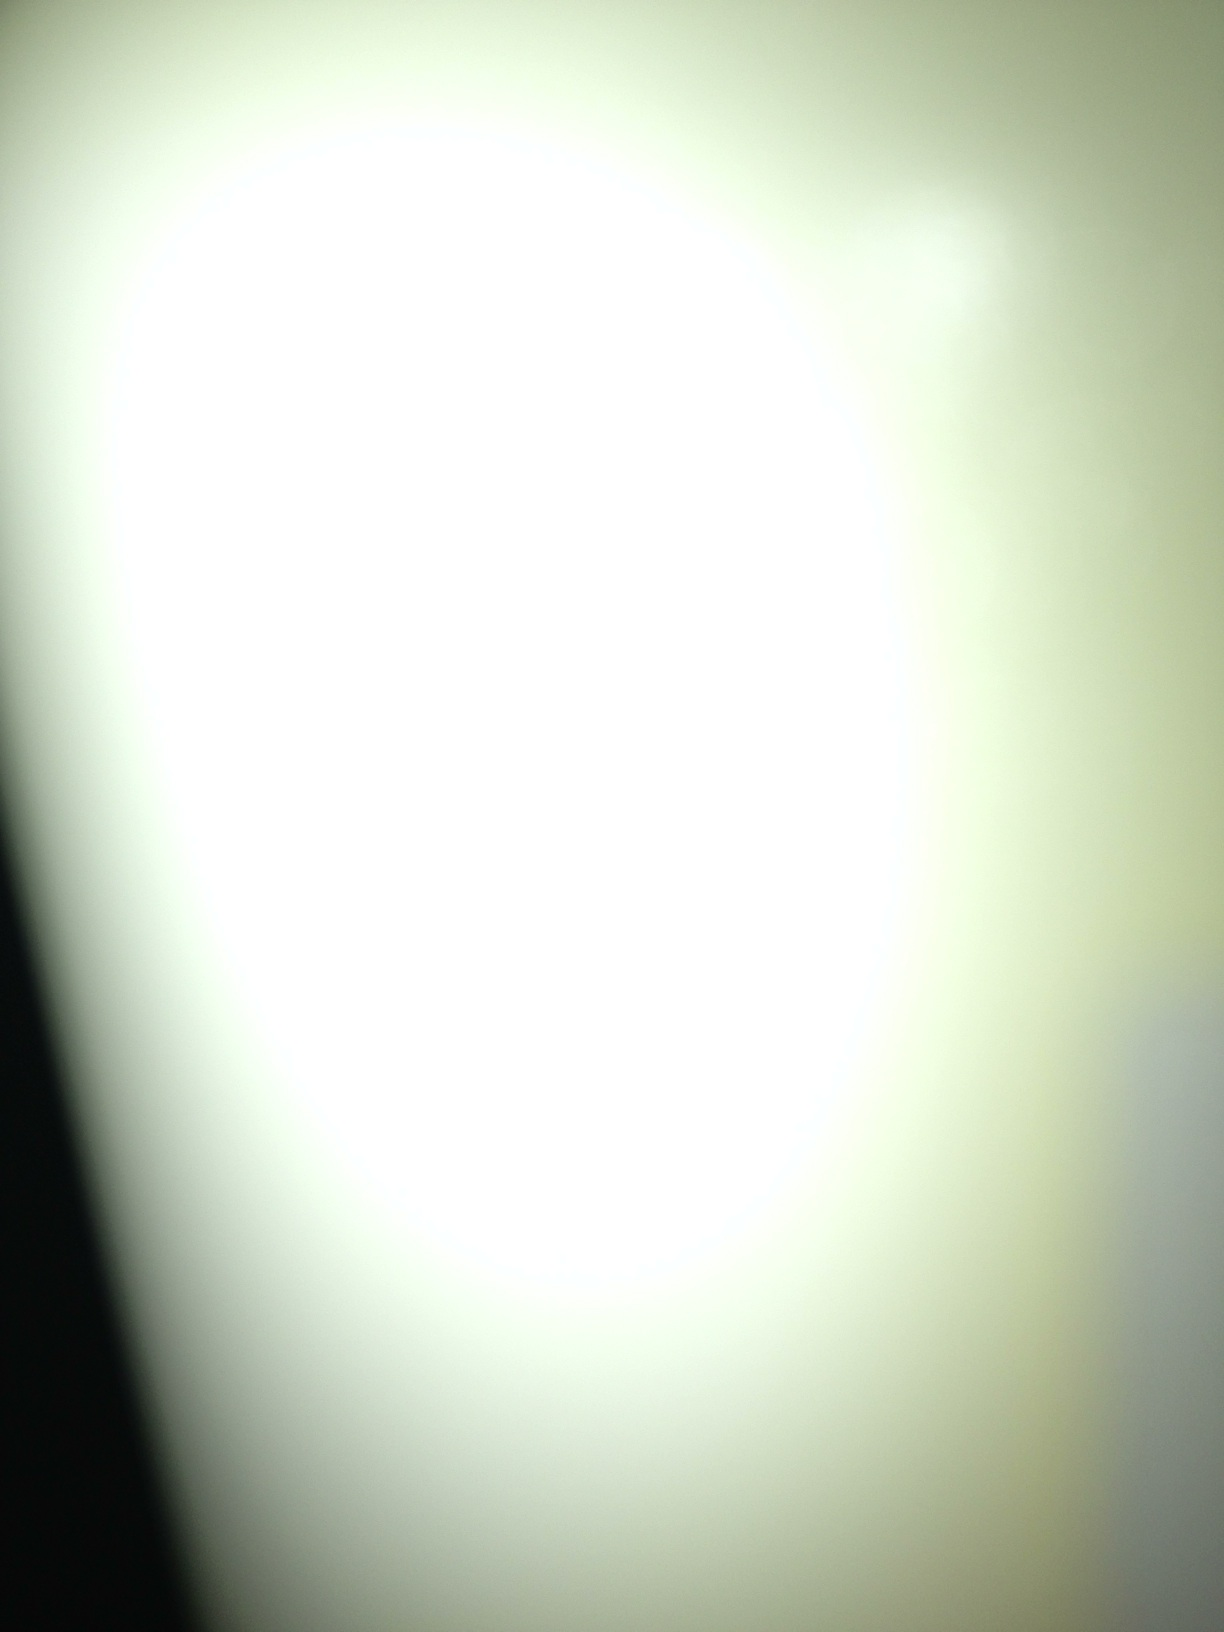Imagine this image as part of a larger scene. What story could it be telling? Imagine this image as a glimpse into a vast, otherworldly landscape. It could be a portal opening into another dimension, with the bright white light signifying the passage between realities. The surrounding darkness might hide unknown realms waiting to be explored. The story could follow a brave explorer venturing into this portal, encountering enigmatic beings and unraveling the mysteries of this new world. 